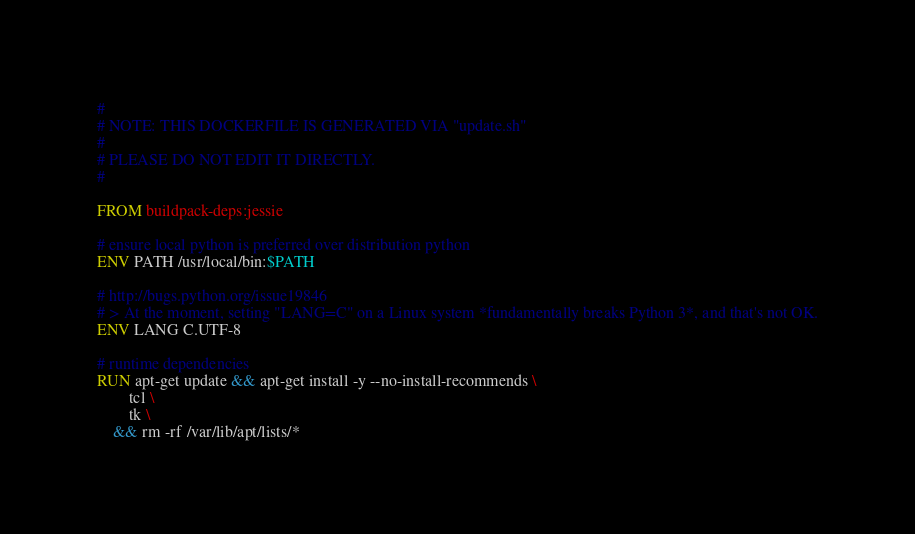Convert code to text. <code><loc_0><loc_0><loc_500><loc_500><_Dockerfile_>#
# NOTE: THIS DOCKERFILE IS GENERATED VIA "update.sh"
#
# PLEASE DO NOT EDIT IT DIRECTLY.
#

FROM buildpack-deps:jessie

# ensure local python is preferred over distribution python
ENV PATH /usr/local/bin:$PATH

# http://bugs.python.org/issue19846
# > At the moment, setting "LANG=C" on a Linux system *fundamentally breaks Python 3*, and that's not OK.
ENV LANG C.UTF-8

# runtime dependencies
RUN apt-get update && apt-get install -y --no-install-recommends \
		tcl \
		tk \
	&& rm -rf /var/lib/apt/lists/*
</code> 